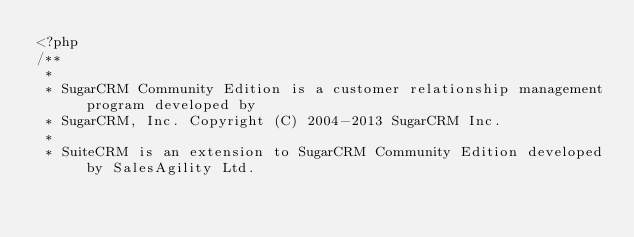Convert code to text. <code><loc_0><loc_0><loc_500><loc_500><_PHP_><?php
/**
 *
 * SugarCRM Community Edition is a customer relationship management program developed by
 * SugarCRM, Inc. Copyright (C) 2004-2013 SugarCRM Inc.
 *
 * SuiteCRM is an extension to SugarCRM Community Edition developed by SalesAgility Ltd.</code> 